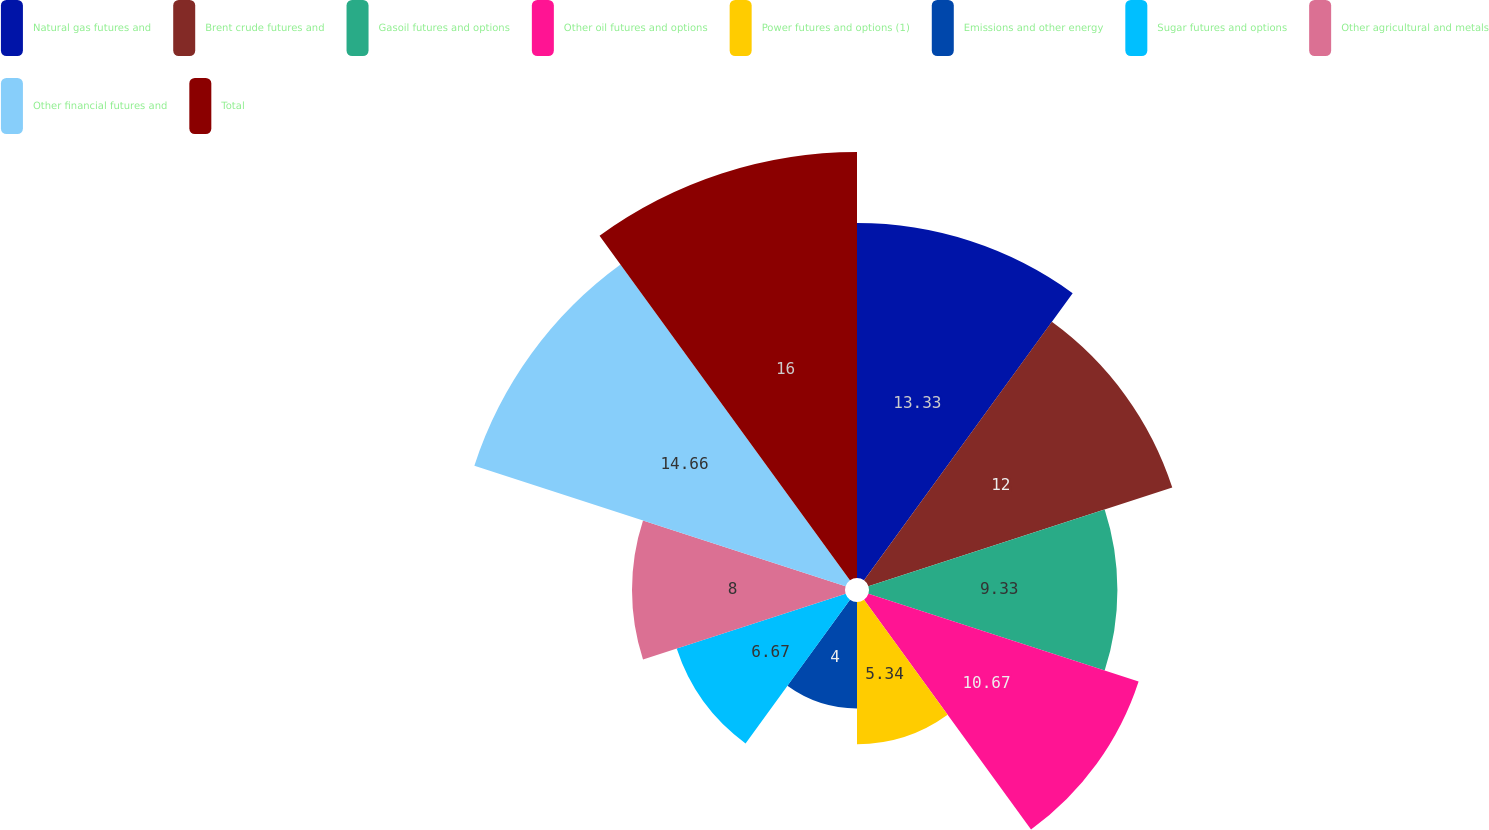Convert chart to OTSL. <chart><loc_0><loc_0><loc_500><loc_500><pie_chart><fcel>Natural gas futures and<fcel>Brent crude futures and<fcel>Gasoil futures and options<fcel>Other oil futures and options<fcel>Power futures and options (1)<fcel>Emissions and other energy<fcel>Sugar futures and options<fcel>Other agricultural and metals<fcel>Other financial futures and<fcel>Total<nl><fcel>13.33%<fcel>12.0%<fcel>9.33%<fcel>10.67%<fcel>5.34%<fcel>4.0%<fcel>6.67%<fcel>8.0%<fcel>14.66%<fcel>16.0%<nl></chart> 